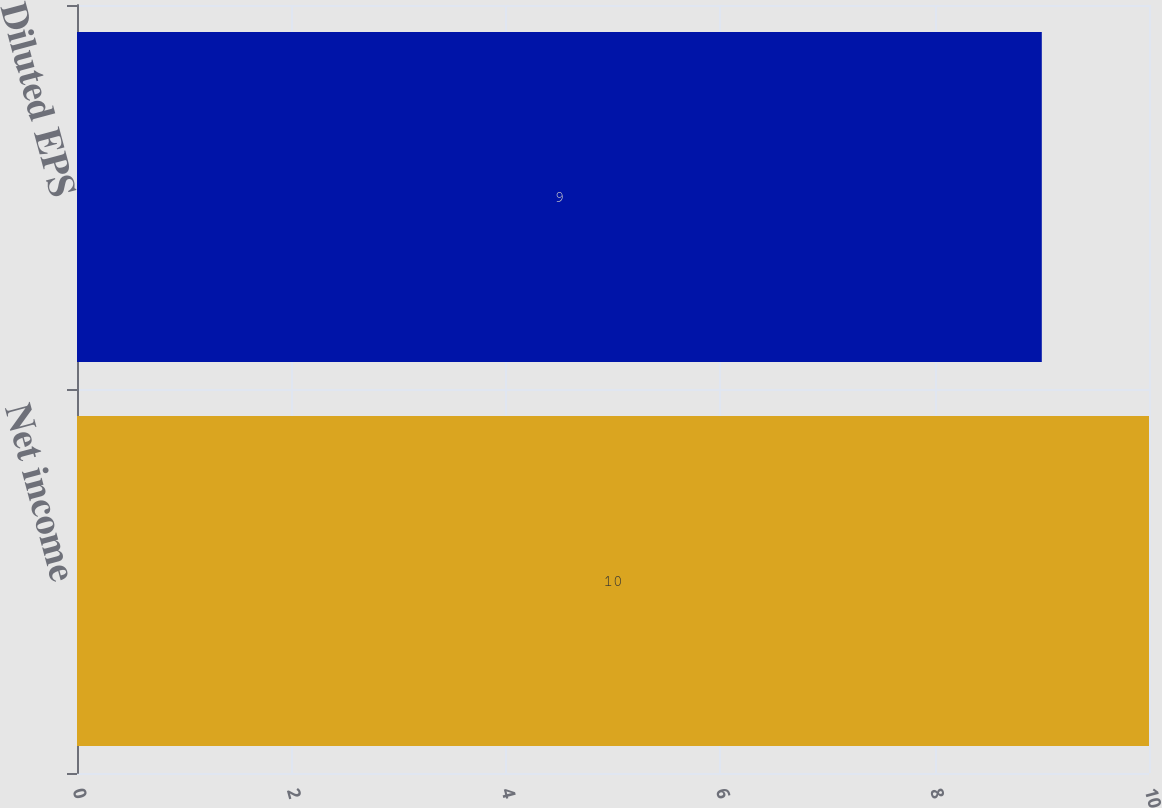Convert chart. <chart><loc_0><loc_0><loc_500><loc_500><bar_chart><fcel>Net income<fcel>Diluted EPS<nl><fcel>10<fcel>9<nl></chart> 